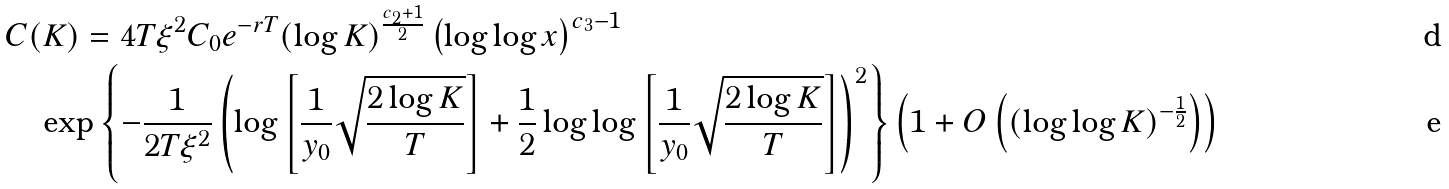Convert formula to latex. <formula><loc_0><loc_0><loc_500><loc_500>& C ( K ) = 4 T \xi ^ { 2 } C _ { 0 } e ^ { - r T } ( \log K ) ^ { \frac { c _ { 2 } + 1 } { 2 } } \left ( \log \log x \right ) ^ { c _ { 3 } - 1 } \\ & \quad \exp \left \{ - \frac { 1 } { 2 T \xi ^ { 2 } } \left ( \log \left [ \frac { 1 } { y _ { 0 } } \sqrt { \frac { 2 \log K } { T } } \right ] + \frac { 1 } { 2 } \log \log \left [ \frac { 1 } { y _ { 0 } } \sqrt { \frac { 2 \log K } { T } } \right ] \right ) ^ { 2 } \right \} \left ( 1 + O \left ( ( \log \log K ) ^ { - \frac { 1 } { 2 } } \right ) \right )</formula> 